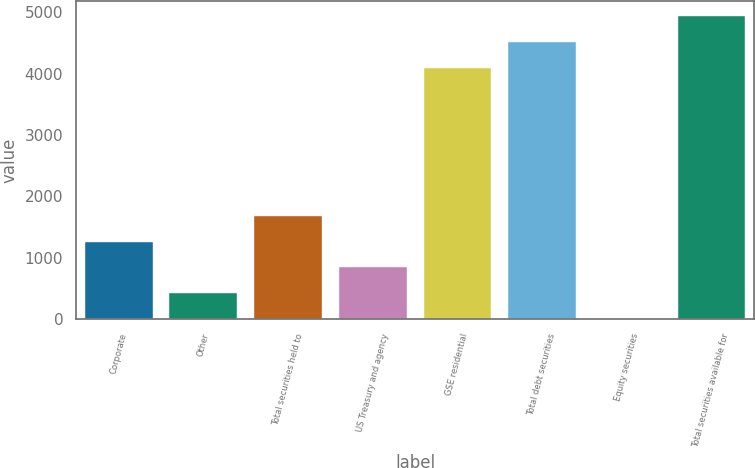Convert chart. <chart><loc_0><loc_0><loc_500><loc_500><bar_chart><fcel>Corporate<fcel>Other<fcel>Total securities held to<fcel>US Treasury and agency<fcel>GSE residential<fcel>Total debt securities<fcel>Equity securities<fcel>Total securities available for<nl><fcel>1262.6<fcel>421<fcel>1683.4<fcel>841.8<fcel>4096.4<fcel>4517.2<fcel>0.2<fcel>4938<nl></chart> 